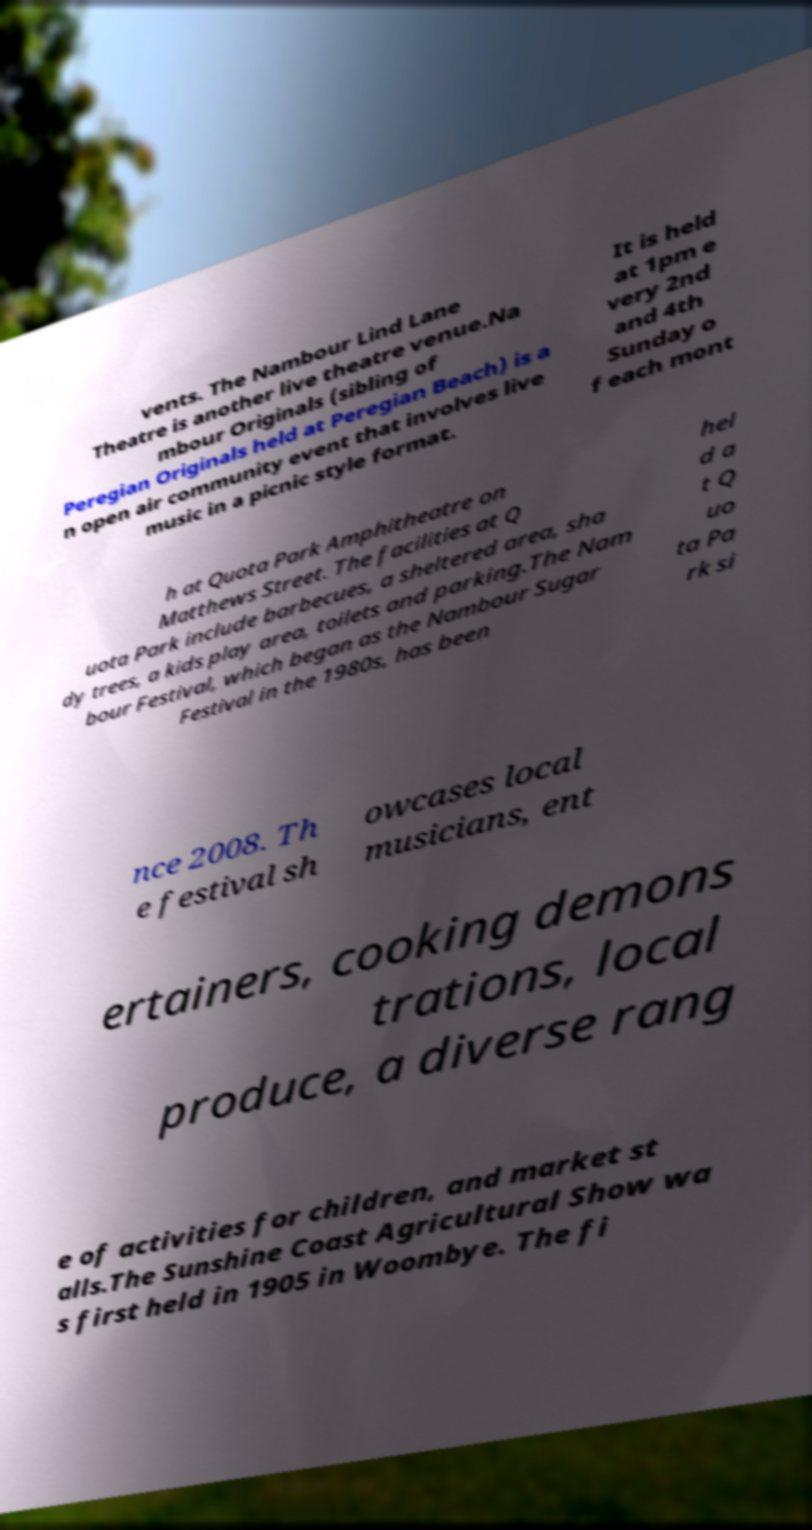There's text embedded in this image that I need extracted. Can you transcribe it verbatim? vents. The Nambour Lind Lane Theatre is another live theatre venue.Na mbour Originals (sibling of Peregian Originals held at Peregian Beach) is a n open air community event that involves live music in a picnic style format. It is held at 1pm e very 2nd and 4th Sunday o f each mont h at Quota Park Amphitheatre on Matthews Street. The facilities at Q uota Park include barbecues, a sheltered area, sha dy trees, a kids play area, toilets and parking.The Nam bour Festival, which began as the Nambour Sugar Festival in the 1980s, has been hel d a t Q uo ta Pa rk si nce 2008. Th e festival sh owcases local musicians, ent ertainers, cooking demons trations, local produce, a diverse rang e of activities for children, and market st alls.The Sunshine Coast Agricultural Show wa s first held in 1905 in Woombye. The fi 